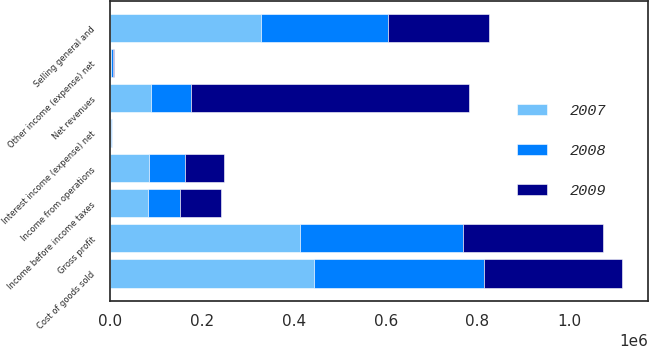<chart> <loc_0><loc_0><loc_500><loc_500><stacked_bar_chart><ecel><fcel>Net revenues<fcel>Cost of goods sold<fcel>Gross profit<fcel>Selling general and<fcel>Income from operations<fcel>Interest income (expense) net<fcel>Other income (expense) net<fcel>Income before income taxes<nl><fcel>2007<fcel>87654<fcel>443386<fcel>413025<fcel>327752<fcel>85273<fcel>2344<fcel>511<fcel>82418<nl><fcel>2008<fcel>87654<fcel>370296<fcel>354948<fcel>278023<fcel>76925<fcel>850<fcel>6175<fcel>69900<nl><fcel>2009<fcel>606561<fcel>301517<fcel>305044<fcel>218779<fcel>86265<fcel>749<fcel>2029<fcel>89043<nl></chart> 